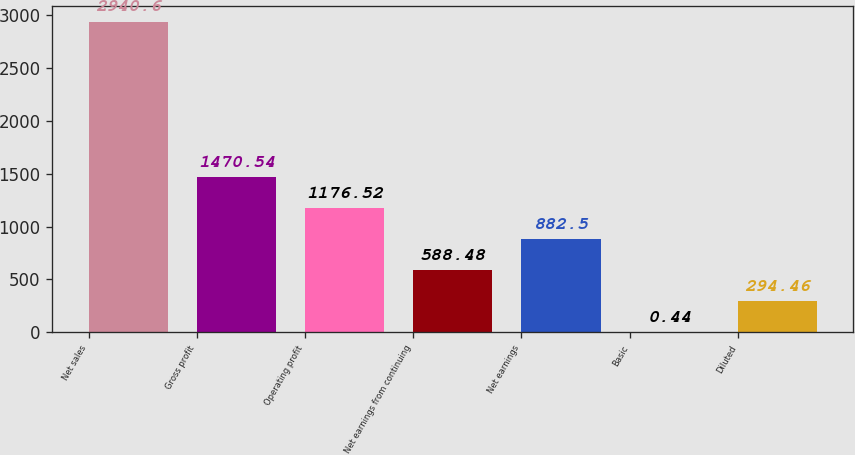Convert chart. <chart><loc_0><loc_0><loc_500><loc_500><bar_chart><fcel>Net sales<fcel>Gross profit<fcel>Operating profit<fcel>Net earnings from continuing<fcel>Net earnings<fcel>Basic<fcel>Diluted<nl><fcel>2940.6<fcel>1470.54<fcel>1176.52<fcel>588.48<fcel>882.5<fcel>0.44<fcel>294.46<nl></chart> 